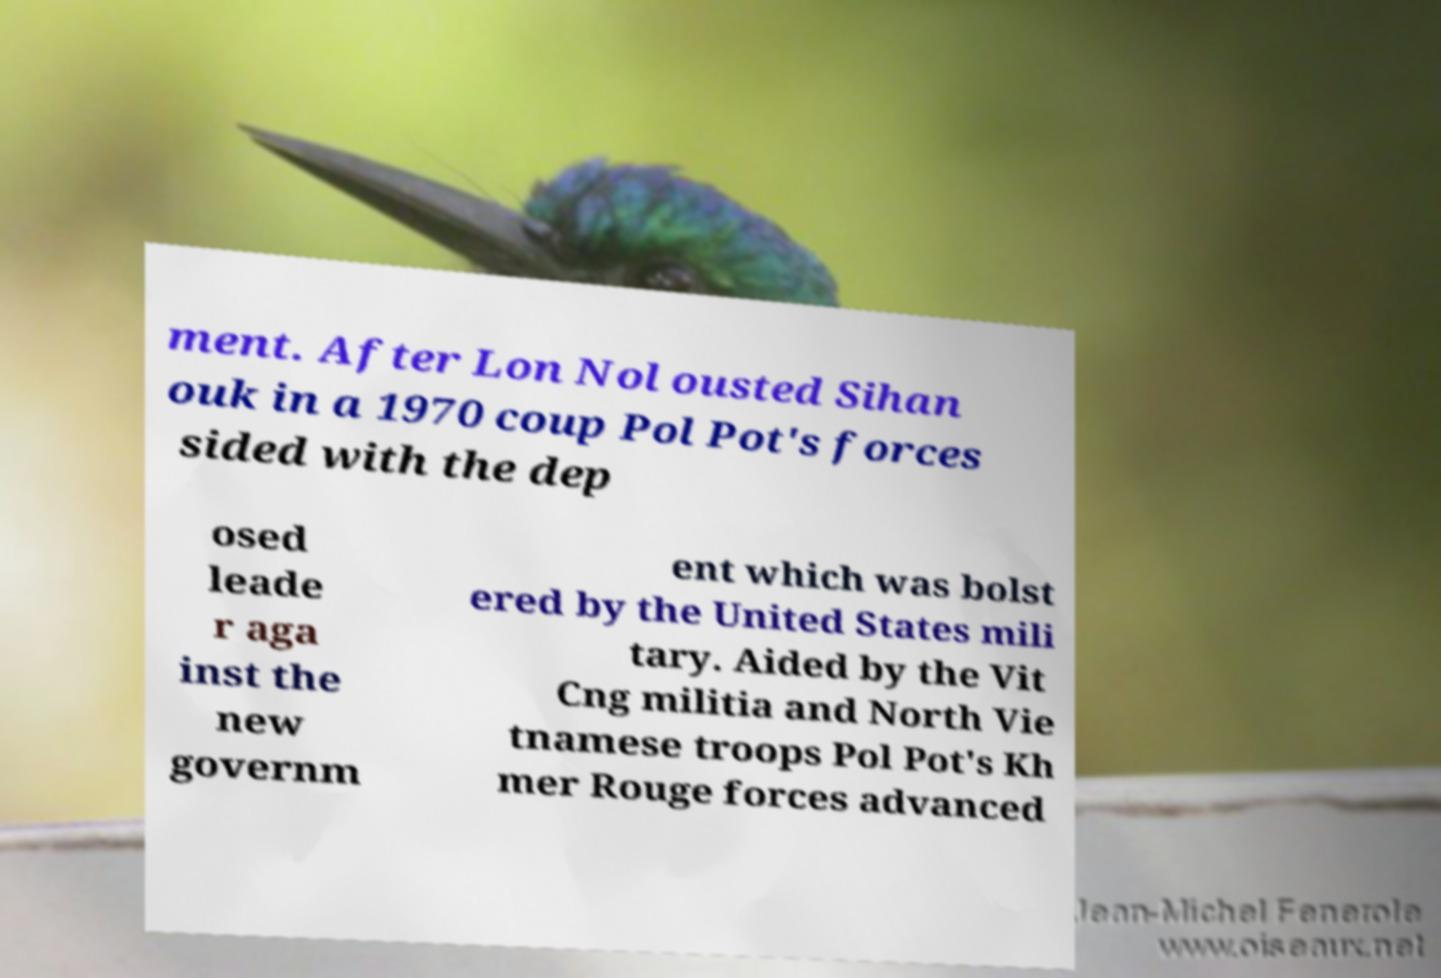Please identify and transcribe the text found in this image. ment. After Lon Nol ousted Sihan ouk in a 1970 coup Pol Pot's forces sided with the dep osed leade r aga inst the new governm ent which was bolst ered by the United States mili tary. Aided by the Vit Cng militia and North Vie tnamese troops Pol Pot's Kh mer Rouge forces advanced 